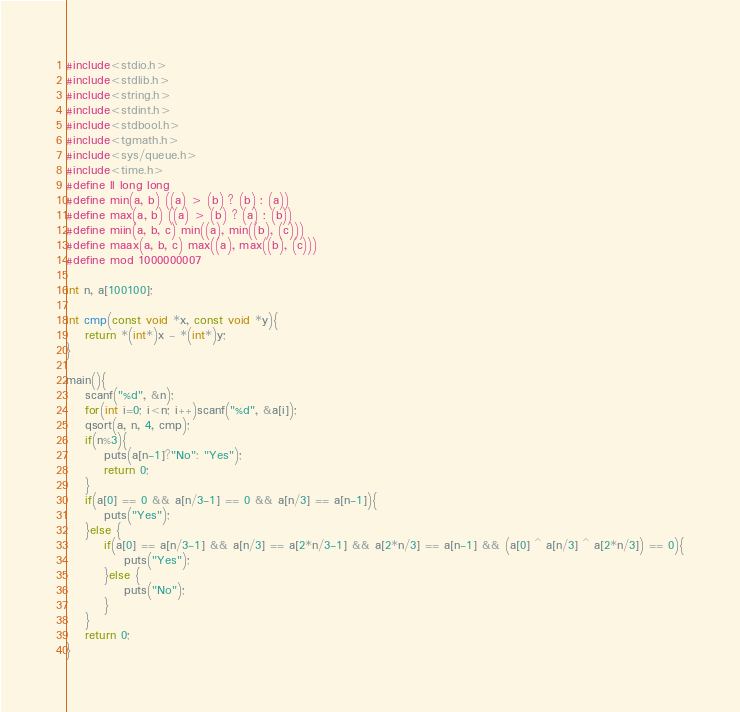Convert code to text. <code><loc_0><loc_0><loc_500><loc_500><_C_>#include<stdio.h>
#include<stdlib.h>
#include<string.h>
#include<stdint.h>
#include<stdbool.h>
#include<tgmath.h>
#include<sys/queue.h>
#include<time.h>
#define ll long long
#define min(a, b) ((a) > (b) ? (b) : (a))
#define max(a, b) ((a) > (b) ? (a) : (b))
#define miin(a, b, c) min((a), min((b), (c)))
#define maax(a, b, c) max((a), max((b), (c)))
#define mod 1000000007

int n, a[100100];

int cmp(const void *x, const void *y){
    return *(int*)x - *(int*)y;
}

main(){
    scanf("%d", &n);
    for(int i=0; i<n; i++)scanf("%d", &a[i]);
    qsort(a, n, 4, cmp);
    if(n%3){
        puts(a[n-1]?"No": "Yes");
        return 0;
    }
    if(a[0] == 0 && a[n/3-1] == 0 && a[n/3] == a[n-1]){
        puts("Yes");
    }else {
        if(a[0] == a[n/3-1] && a[n/3] == a[2*n/3-1] && a[2*n/3] == a[n-1] && (a[0] ^ a[n/3] ^ a[2*n/3]) == 0){
            puts("Yes");
        }else {
            puts("No");
        }
    }
    return 0;
}</code> 